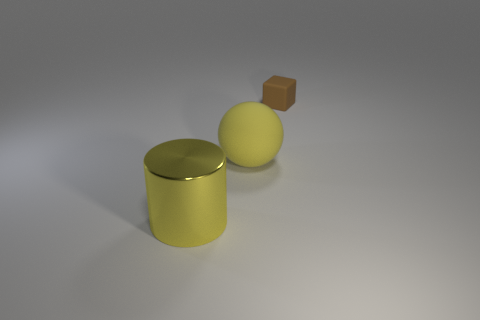Subtract all rubber spheres. Subtract all large shiny cylinders. How many objects are left? 1 Add 2 rubber things. How many rubber things are left? 4 Add 1 shiny things. How many shiny things exist? 2 Add 2 yellow metal things. How many objects exist? 5 Subtract 0 blue cylinders. How many objects are left? 3 Subtract all spheres. How many objects are left? 2 Subtract all cyan cylinders. Subtract all yellow spheres. How many cylinders are left? 1 